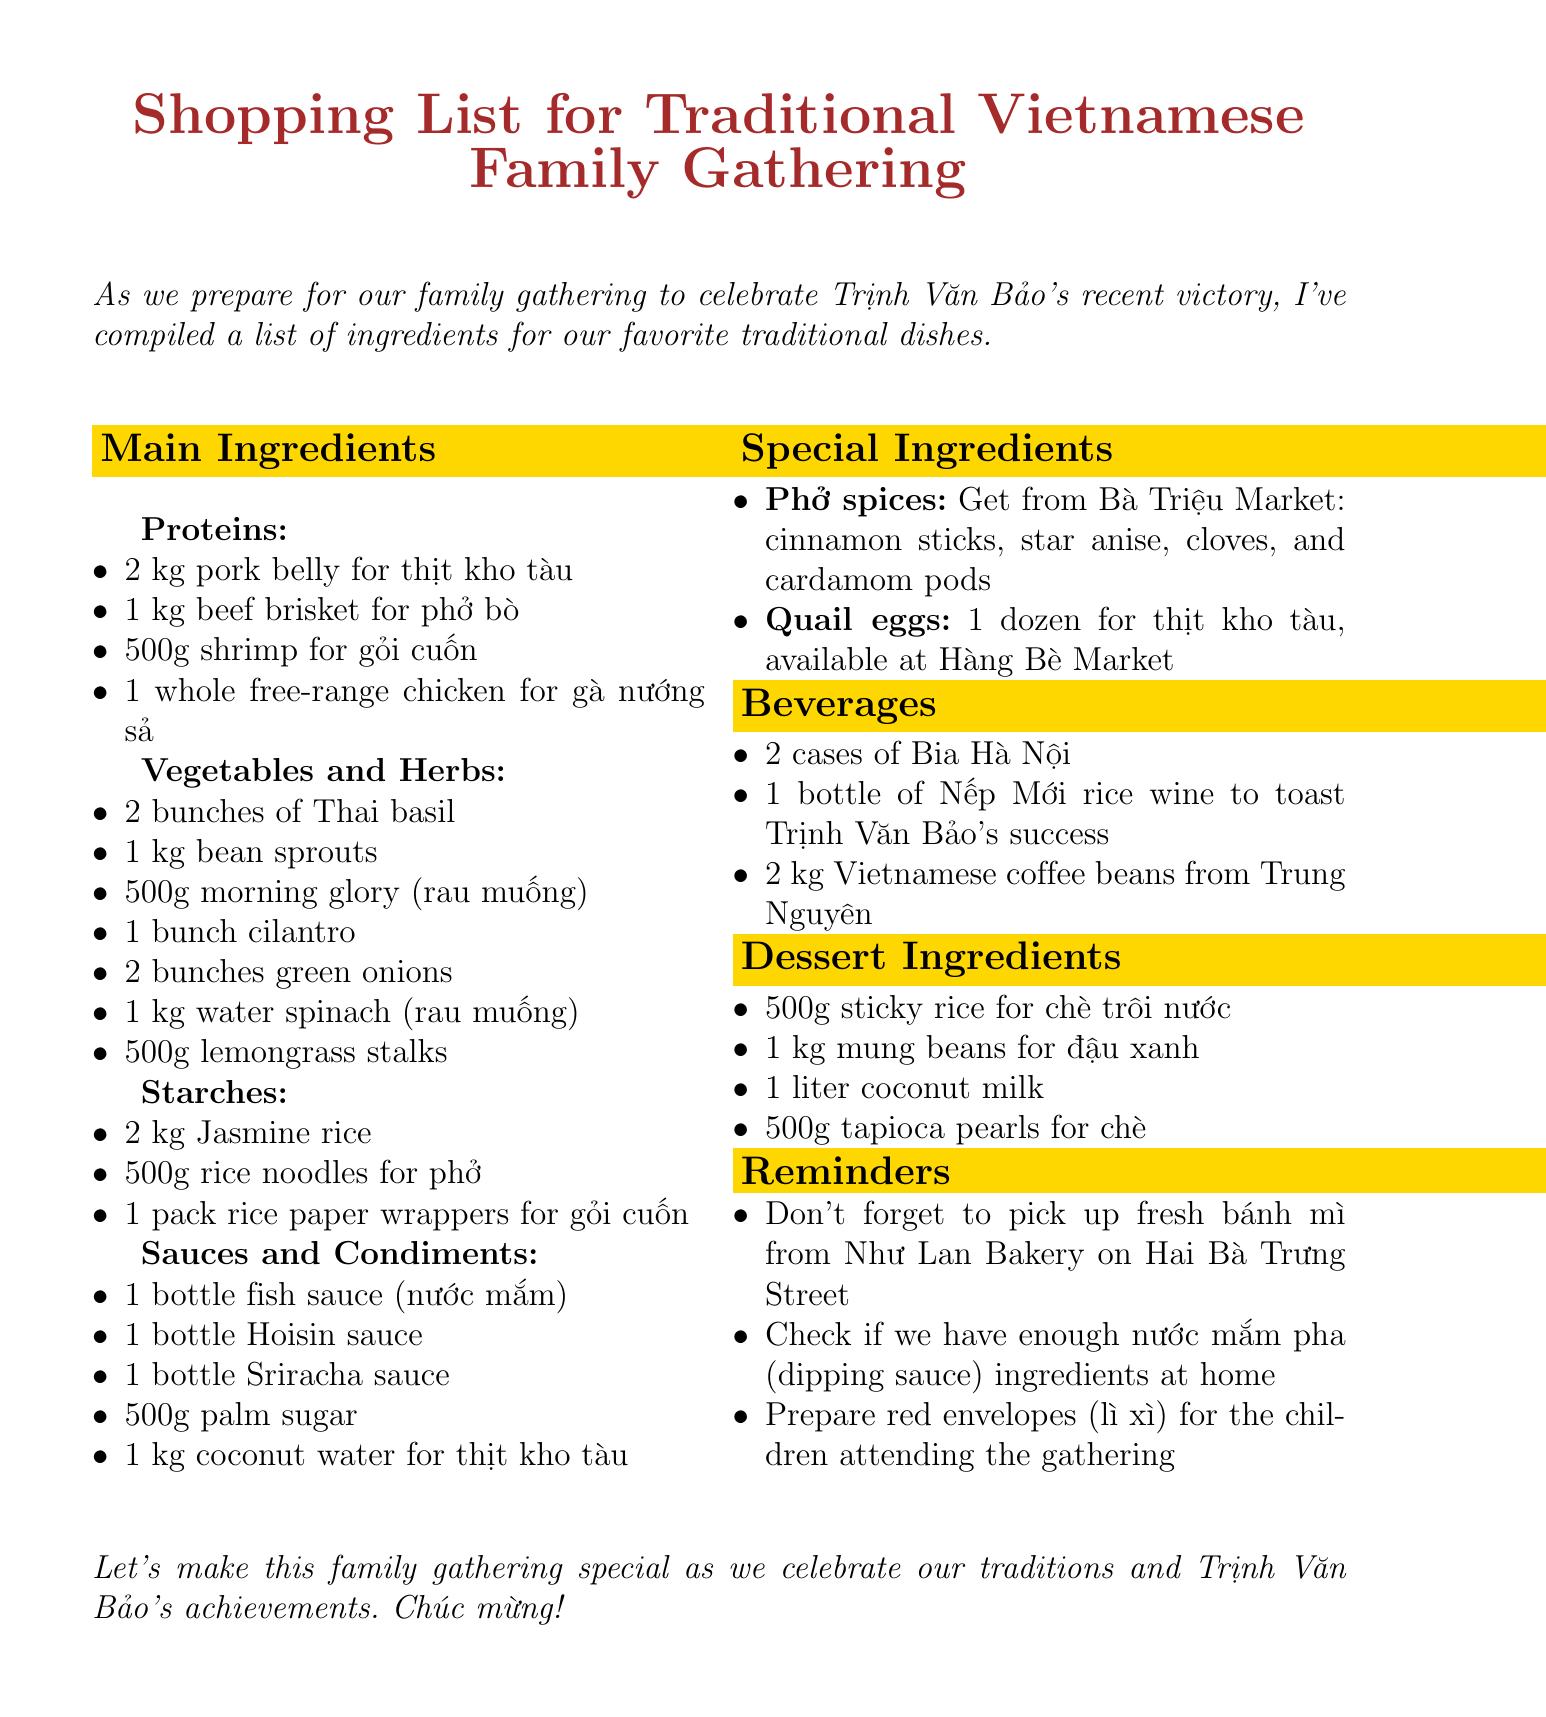What is the memo about? The memo is about preparing a shopping list for ingredients needed for a traditional Vietnamese family gathering.
Answer: Shopping List for Traditional Vietnamese Family Gathering How many kilograms of pork belly are needed? The document specifies the amount of pork belly required for thịt kho tàu.
Answer: 2 kg What type of rice is listed as a starch? The memo mentions a specific type of rice in the starches category.
Answer: Jasmine rice Which market should I visit for phở spices? The document mentions a specific market where phở spices can be purchased.
Answer: Bà Triệu Market What is a special ingredient listed in the document? The memo highlights unique ingredients that are essential for certain dishes.
Answer: Quail eggs How much coconut water is required? The document specifies the amount of coconut water required for thịt kho tàu.
Answer: 1 kg What is a reminder mentioned in the memo? The document includes several reminders related to preparations for the gathering.
Answer: Don't forget to pick up fresh bánh mì from Như Lan Bakery How many cases of Bia Hà Nội are needed? The document states the amount of beverage required for the family gathering.
Answer: 2 cases What is the total weight of sticky rice needed for dessert? The memo lists the amount of sticky rice required for making a specific dessert.
Answer: 500g 